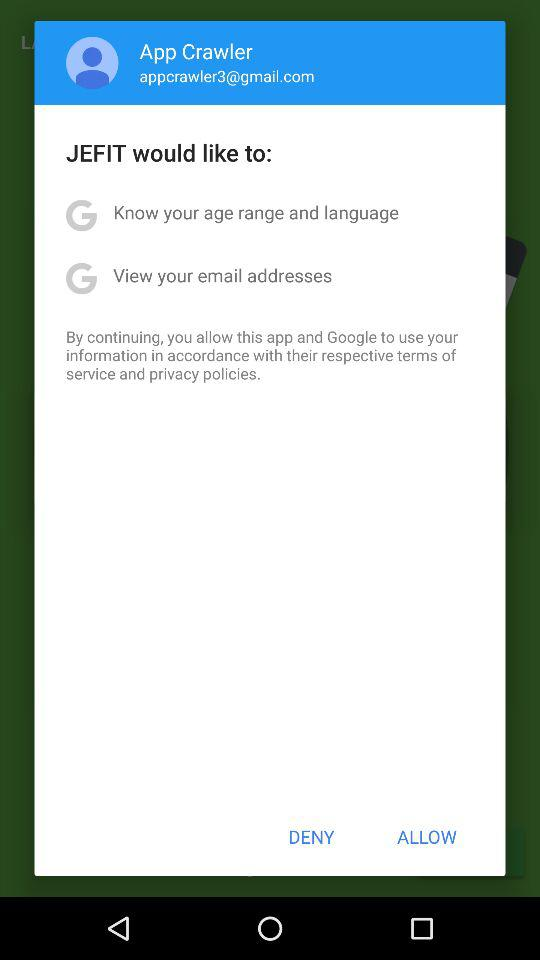How many permissions does JEFIT want to access?
Answer the question using a single word or phrase. 2 